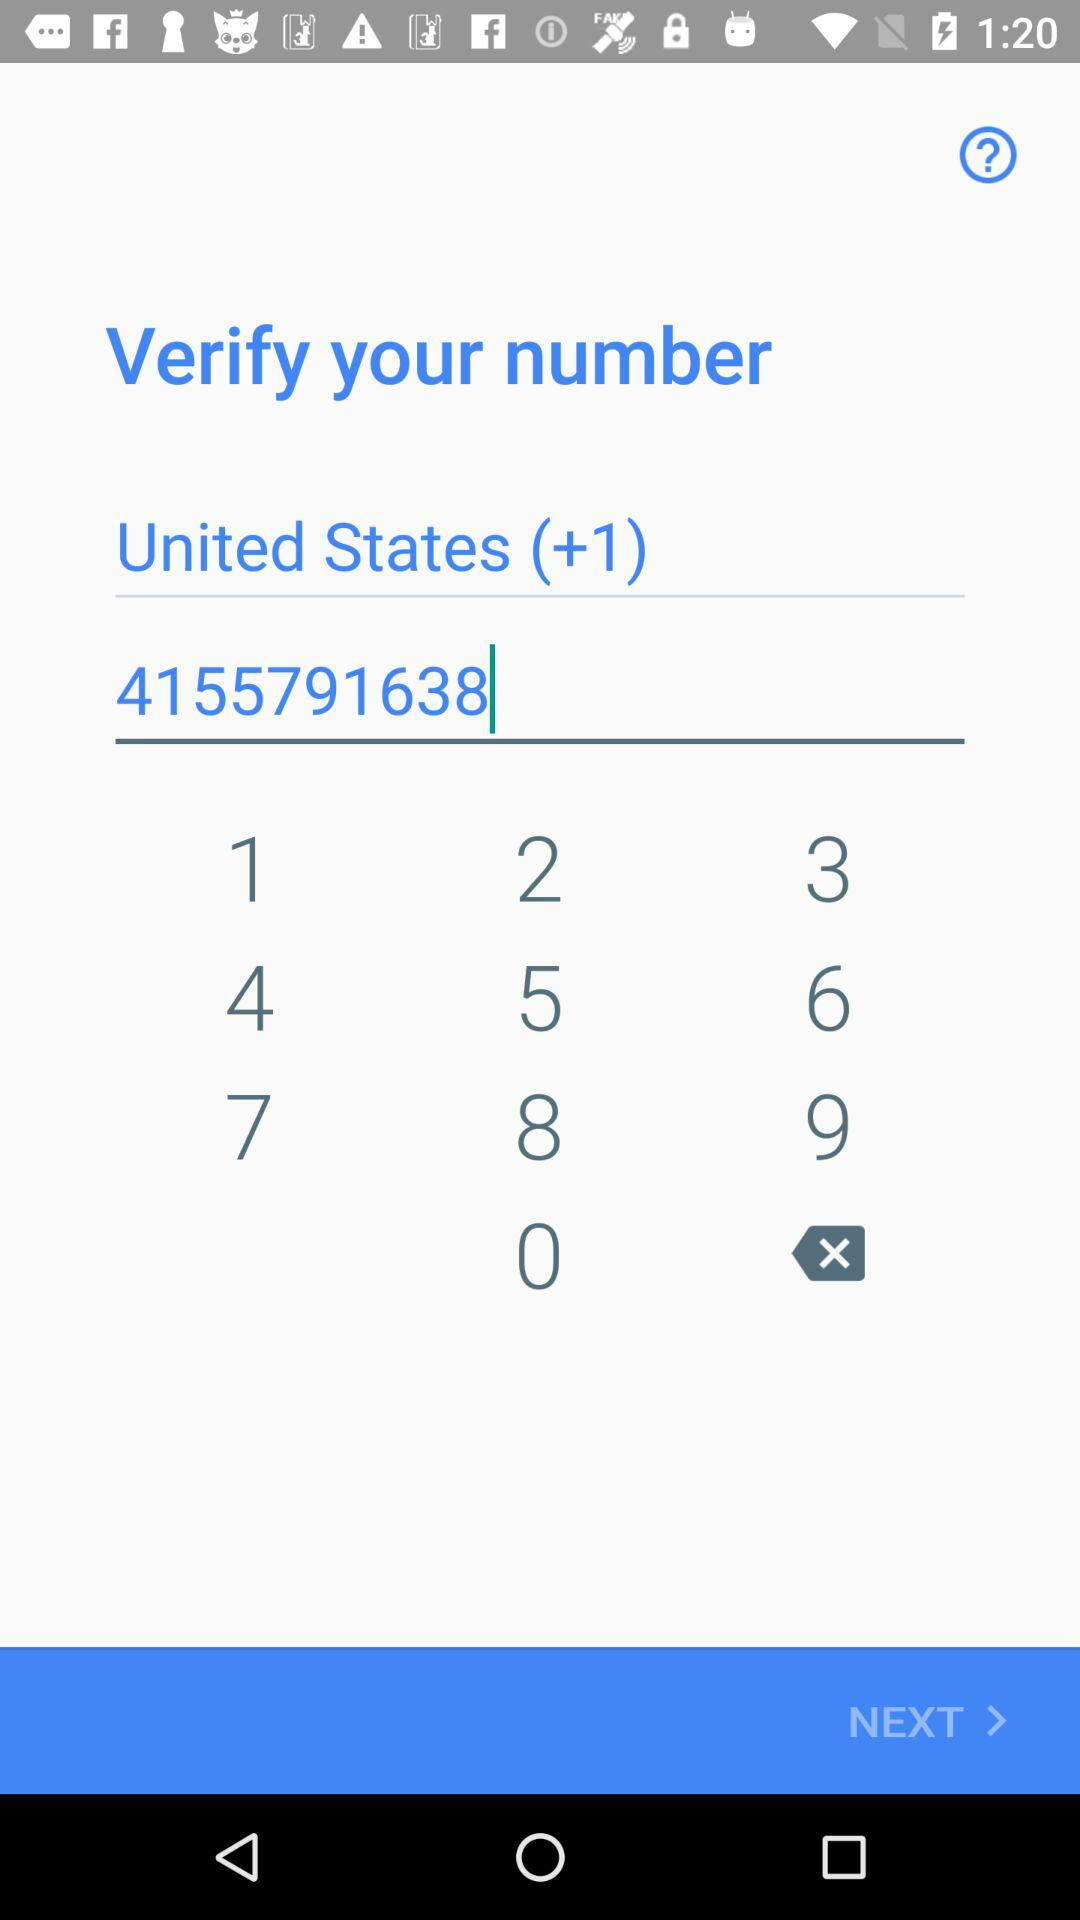How will the phone number be verified?
When the provided information is insufficient, respond with <no answer>. <no answer> 